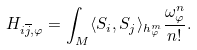<formula> <loc_0><loc_0><loc_500><loc_500>H _ { i \overline { j } , \varphi } = \int _ { M } \langle S _ { i } , S _ { j } \rangle _ { h ^ { m } _ { \varphi } } \frac { \omega _ { \varphi } ^ { n } } { n ! } .</formula> 